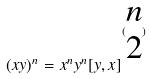<formula> <loc_0><loc_0><loc_500><loc_500>( x y ) ^ { n } = x ^ { n } y ^ { n } [ y , x ] ^ { ( \begin{matrix} n \\ 2 \end{matrix} ) }</formula> 